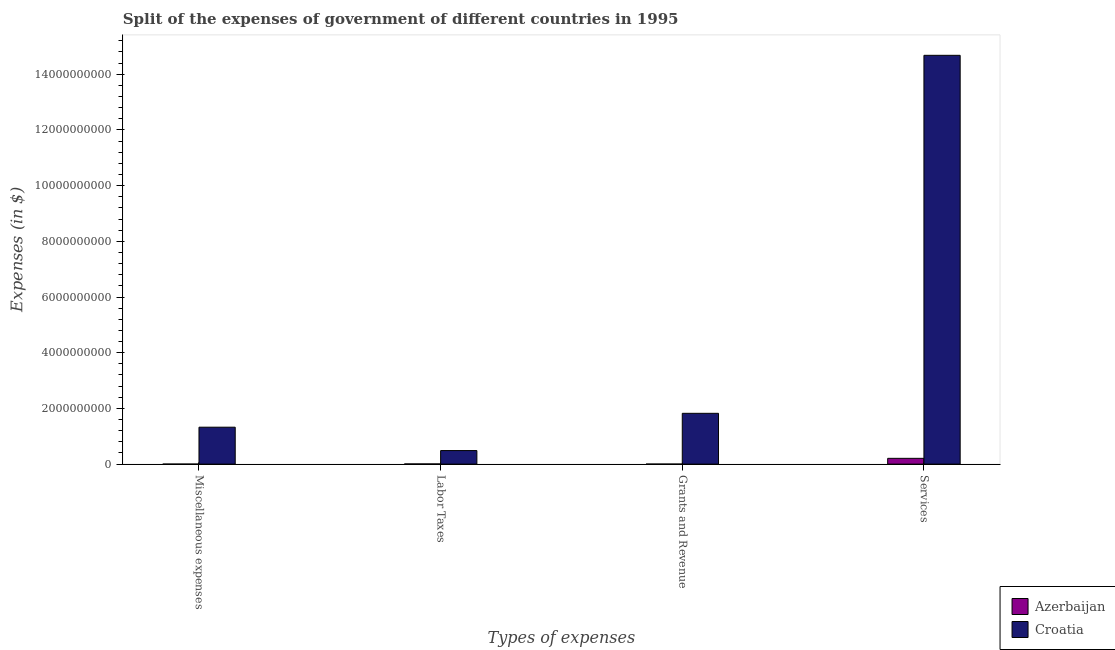How many different coloured bars are there?
Provide a short and direct response. 2. Are the number of bars per tick equal to the number of legend labels?
Your answer should be compact. Yes. How many bars are there on the 2nd tick from the left?
Keep it short and to the point. 2. What is the label of the 1st group of bars from the left?
Provide a short and direct response. Miscellaneous expenses. What is the amount spent on services in Azerbaijan?
Your response must be concise. 2.08e+08. Across all countries, what is the maximum amount spent on labor taxes?
Your answer should be compact. 4.86e+08. Across all countries, what is the minimum amount spent on services?
Ensure brevity in your answer.  2.08e+08. In which country was the amount spent on labor taxes maximum?
Your answer should be compact. Croatia. In which country was the amount spent on grants and revenue minimum?
Offer a terse response. Azerbaijan. What is the total amount spent on services in the graph?
Offer a very short reply. 1.49e+1. What is the difference between the amount spent on services in Azerbaijan and that in Croatia?
Your answer should be compact. -1.45e+1. What is the difference between the amount spent on services in Azerbaijan and the amount spent on grants and revenue in Croatia?
Offer a very short reply. -1.62e+09. What is the average amount spent on miscellaneous expenses per country?
Your answer should be compact. 6.63e+08. What is the difference between the amount spent on grants and revenue and amount spent on miscellaneous expenses in Azerbaijan?
Provide a succinct answer. 6.31e+05. In how many countries, is the amount spent on labor taxes greater than 2400000000 $?
Your answer should be compact. 0. What is the ratio of the amount spent on labor taxes in Azerbaijan to that in Croatia?
Your answer should be very brief. 0.01. Is the amount spent on services in Croatia less than that in Azerbaijan?
Your answer should be compact. No. What is the difference between the highest and the second highest amount spent on miscellaneous expenses?
Your answer should be very brief. 1.33e+09. What is the difference between the highest and the lowest amount spent on services?
Provide a short and direct response. 1.45e+1. What does the 2nd bar from the left in Labor Taxes represents?
Make the answer very short. Croatia. What does the 2nd bar from the right in Grants and Revenue represents?
Offer a very short reply. Azerbaijan. How many bars are there?
Ensure brevity in your answer.  8. How many countries are there in the graph?
Provide a succinct answer. 2. What is the difference between two consecutive major ticks on the Y-axis?
Give a very brief answer. 2.00e+09. Does the graph contain any zero values?
Offer a terse response. No. Does the graph contain grids?
Keep it short and to the point. No. Where does the legend appear in the graph?
Keep it short and to the point. Bottom right. How are the legend labels stacked?
Give a very brief answer. Vertical. What is the title of the graph?
Your answer should be compact. Split of the expenses of government of different countries in 1995. Does "Greenland" appear as one of the legend labels in the graph?
Keep it short and to the point. No. What is the label or title of the X-axis?
Provide a succinct answer. Types of expenses. What is the label or title of the Y-axis?
Your answer should be very brief. Expenses (in $). What is the Expenses (in $) in Azerbaijan in Miscellaneous expenses?
Offer a terse response. 3.14e+05. What is the Expenses (in $) in Croatia in Miscellaneous expenses?
Keep it short and to the point. 1.33e+09. What is the Expenses (in $) of Azerbaijan in Labor Taxes?
Ensure brevity in your answer.  6.16e+06. What is the Expenses (in $) in Croatia in Labor Taxes?
Provide a short and direct response. 4.86e+08. What is the Expenses (in $) of Azerbaijan in Grants and Revenue?
Make the answer very short. 9.45e+05. What is the Expenses (in $) in Croatia in Grants and Revenue?
Provide a short and direct response. 1.82e+09. What is the Expenses (in $) of Azerbaijan in Services?
Make the answer very short. 2.08e+08. What is the Expenses (in $) of Croatia in Services?
Provide a short and direct response. 1.47e+1. Across all Types of expenses, what is the maximum Expenses (in $) of Azerbaijan?
Offer a very short reply. 2.08e+08. Across all Types of expenses, what is the maximum Expenses (in $) of Croatia?
Your answer should be compact. 1.47e+1. Across all Types of expenses, what is the minimum Expenses (in $) in Azerbaijan?
Your answer should be very brief. 3.14e+05. Across all Types of expenses, what is the minimum Expenses (in $) in Croatia?
Ensure brevity in your answer.  4.86e+08. What is the total Expenses (in $) in Azerbaijan in the graph?
Keep it short and to the point. 2.15e+08. What is the total Expenses (in $) of Croatia in the graph?
Your response must be concise. 1.83e+1. What is the difference between the Expenses (in $) in Azerbaijan in Miscellaneous expenses and that in Labor Taxes?
Ensure brevity in your answer.  -5.85e+06. What is the difference between the Expenses (in $) in Croatia in Miscellaneous expenses and that in Labor Taxes?
Your response must be concise. 8.39e+08. What is the difference between the Expenses (in $) in Azerbaijan in Miscellaneous expenses and that in Grants and Revenue?
Your answer should be compact. -6.31e+05. What is the difference between the Expenses (in $) in Croatia in Miscellaneous expenses and that in Grants and Revenue?
Offer a terse response. -4.98e+08. What is the difference between the Expenses (in $) in Azerbaijan in Miscellaneous expenses and that in Services?
Make the answer very short. -2.07e+08. What is the difference between the Expenses (in $) in Croatia in Miscellaneous expenses and that in Services?
Offer a very short reply. -1.34e+1. What is the difference between the Expenses (in $) in Azerbaijan in Labor Taxes and that in Grants and Revenue?
Your answer should be very brief. 5.22e+06. What is the difference between the Expenses (in $) of Croatia in Labor Taxes and that in Grants and Revenue?
Your answer should be very brief. -1.34e+09. What is the difference between the Expenses (in $) in Azerbaijan in Labor Taxes and that in Services?
Offer a terse response. -2.01e+08. What is the difference between the Expenses (in $) of Croatia in Labor Taxes and that in Services?
Offer a terse response. -1.42e+1. What is the difference between the Expenses (in $) in Azerbaijan in Grants and Revenue and that in Services?
Make the answer very short. -2.07e+08. What is the difference between the Expenses (in $) in Croatia in Grants and Revenue and that in Services?
Your answer should be very brief. -1.29e+1. What is the difference between the Expenses (in $) in Azerbaijan in Miscellaneous expenses and the Expenses (in $) in Croatia in Labor Taxes?
Offer a very short reply. -4.86e+08. What is the difference between the Expenses (in $) in Azerbaijan in Miscellaneous expenses and the Expenses (in $) in Croatia in Grants and Revenue?
Ensure brevity in your answer.  -1.82e+09. What is the difference between the Expenses (in $) in Azerbaijan in Miscellaneous expenses and the Expenses (in $) in Croatia in Services?
Make the answer very short. -1.47e+1. What is the difference between the Expenses (in $) in Azerbaijan in Labor Taxes and the Expenses (in $) in Croatia in Grants and Revenue?
Provide a short and direct response. -1.82e+09. What is the difference between the Expenses (in $) of Azerbaijan in Labor Taxes and the Expenses (in $) of Croatia in Services?
Ensure brevity in your answer.  -1.47e+1. What is the difference between the Expenses (in $) in Azerbaijan in Grants and Revenue and the Expenses (in $) in Croatia in Services?
Provide a succinct answer. -1.47e+1. What is the average Expenses (in $) in Azerbaijan per Types of expenses?
Ensure brevity in your answer.  5.37e+07. What is the average Expenses (in $) in Croatia per Types of expenses?
Provide a short and direct response. 4.58e+09. What is the difference between the Expenses (in $) of Azerbaijan and Expenses (in $) of Croatia in Miscellaneous expenses?
Offer a terse response. -1.33e+09. What is the difference between the Expenses (in $) in Azerbaijan and Expenses (in $) in Croatia in Labor Taxes?
Give a very brief answer. -4.80e+08. What is the difference between the Expenses (in $) of Azerbaijan and Expenses (in $) of Croatia in Grants and Revenue?
Your answer should be compact. -1.82e+09. What is the difference between the Expenses (in $) in Azerbaijan and Expenses (in $) in Croatia in Services?
Your answer should be compact. -1.45e+1. What is the ratio of the Expenses (in $) of Azerbaijan in Miscellaneous expenses to that in Labor Taxes?
Your response must be concise. 0.05. What is the ratio of the Expenses (in $) of Croatia in Miscellaneous expenses to that in Labor Taxes?
Your response must be concise. 2.73. What is the ratio of the Expenses (in $) of Azerbaijan in Miscellaneous expenses to that in Grants and Revenue?
Make the answer very short. 0.33. What is the ratio of the Expenses (in $) in Croatia in Miscellaneous expenses to that in Grants and Revenue?
Your answer should be compact. 0.73. What is the ratio of the Expenses (in $) in Azerbaijan in Miscellaneous expenses to that in Services?
Offer a terse response. 0. What is the ratio of the Expenses (in $) of Croatia in Miscellaneous expenses to that in Services?
Your answer should be very brief. 0.09. What is the ratio of the Expenses (in $) in Azerbaijan in Labor Taxes to that in Grants and Revenue?
Make the answer very short. 6.52. What is the ratio of the Expenses (in $) in Croatia in Labor Taxes to that in Grants and Revenue?
Your answer should be compact. 0.27. What is the ratio of the Expenses (in $) of Azerbaijan in Labor Taxes to that in Services?
Your answer should be very brief. 0.03. What is the ratio of the Expenses (in $) in Croatia in Labor Taxes to that in Services?
Keep it short and to the point. 0.03. What is the ratio of the Expenses (in $) of Azerbaijan in Grants and Revenue to that in Services?
Offer a terse response. 0. What is the ratio of the Expenses (in $) of Croatia in Grants and Revenue to that in Services?
Your answer should be compact. 0.12. What is the difference between the highest and the second highest Expenses (in $) in Azerbaijan?
Keep it short and to the point. 2.01e+08. What is the difference between the highest and the second highest Expenses (in $) of Croatia?
Ensure brevity in your answer.  1.29e+1. What is the difference between the highest and the lowest Expenses (in $) of Azerbaijan?
Make the answer very short. 2.07e+08. What is the difference between the highest and the lowest Expenses (in $) of Croatia?
Your response must be concise. 1.42e+1. 